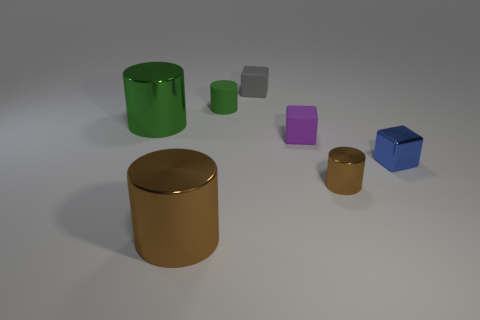How many other objects are there of the same color as the tiny metal block?
Offer a very short reply. 0. Are there any small brown shiny cylinders in front of the small purple object?
Offer a very short reply. Yes. How many things are either large cyan metallic balls or small cylinders that are on the right side of the tiny green thing?
Your response must be concise. 1. Are there any tiny purple objects left of the large thing that is to the left of the large brown metal thing?
Your response must be concise. No. What shape is the metallic thing behind the tiny block in front of the tiny matte cube that is in front of the rubber cylinder?
Keep it short and to the point. Cylinder. What is the color of the small block that is on the left side of the metallic cube and to the right of the gray block?
Provide a short and direct response. Purple. There is a large metallic thing behind the tiny blue shiny thing; what shape is it?
Offer a very short reply. Cylinder. What is the shape of the purple thing that is the same material as the tiny green cylinder?
Give a very brief answer. Cube. How many rubber things are either small blue cubes or tiny gray cubes?
Offer a terse response. 1. There is a small cylinder that is to the left of the tiny thing that is in front of the tiny blue block; what number of matte cubes are on the left side of it?
Your answer should be very brief. 0. 